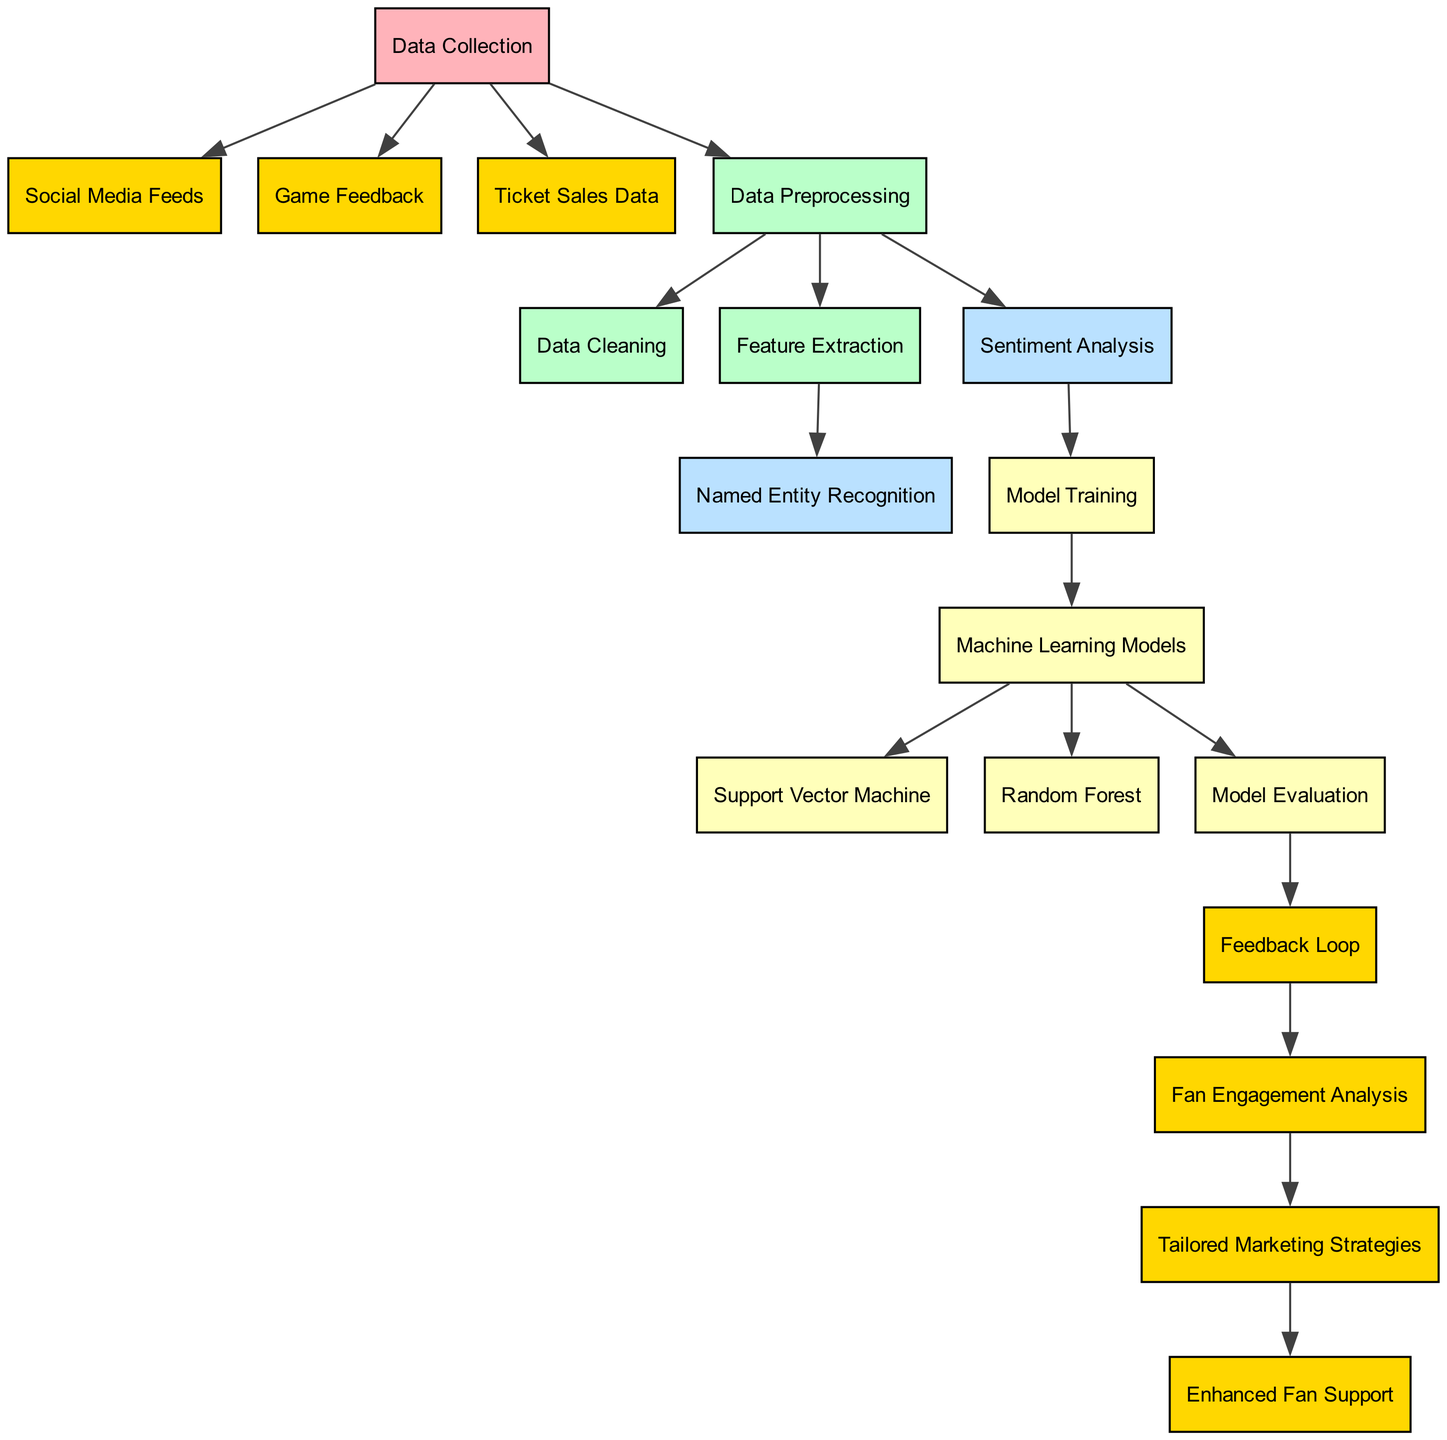What are the three sources of data collection? The diagram shows three sources under the "Data Collection" node: "Social Media Feeds", "Game Feedback", and "Ticket Sales Data".
Answer: Social Media Feeds, Game Feedback, Ticket Sales Data How many nodes are present in the diagram? Counting all the listed nodes in the diagram, there are a total of 17 nodes.
Answer: 17 What is the output of the "Fan Engagement Analysis"? The final output after processing through the analysis and strategies is "Enhanced Fan Support".
Answer: Enhanced Fan Support Which nodes receive input directly from the "Data Collection" node? The three nodes that receive input from "Data Collection" are "Social Media Feeds", "Game Feedback", and "Ticket Sales Data".
Answer: Social Media Feeds, Game Feedback, Ticket Sales Data What is the function of the "Feedback Loop" node? The "Feedback Loop" node connects the evaluation of the models with "Fan Engagement", indicating that it uses feedback to improve fan engagement.
Answer: Improve fan engagement Which algorithm is part of the "Machine Learning Models"? "Support Vector Machine" and "Random Forest" are the algorithms under the "Machine Learning Models" node.
Answer: Support Vector Machine, Random Forest What type of analysis is performed after "Sentiment Analysis"? The diagram shows "Model Training" as the next step after "Sentiment Analysis".
Answer: Model Training What is the role of "Data Cleaning" in the process? "Data Cleaning" is part of the "Data Preprocessing", which prepares the raw data before feature extraction and analysis.
Answer: Prepare raw data Which node follows "Model Evaluation"? The "Feedback Loop" node follows the "Model Evaluation" node in the sequence of operations.
Answer: Feedback Loop 